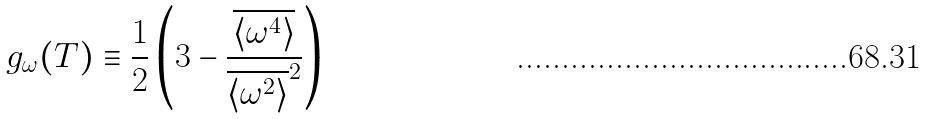<formula> <loc_0><loc_0><loc_500><loc_500>g _ { \omega } ( T ) \equiv \frac { 1 } { 2 } \left ( 3 - \frac { \overline { \langle \omega ^ { 4 } \rangle } } { \overline { \langle \omega ^ { 2 } \rangle } ^ { 2 } } \right )</formula> 